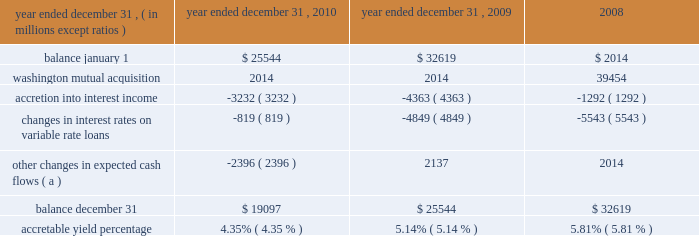Notes to consolidated financial statements 236 jpmorgan chase & co./2010 annual report the table below sets forth the accretable yield activity for the firm 2019s pci consumer loans for the years ended december 31 , 2010 , 2009 and .
( a ) other changes in expected cash flows may vary from period to period as the firm continues to refine its cash flow model and periodically updates model assumptions .
For the years ended december 31 , 2010 and 2009 , other changes in expected cash flows were principally driven by changes in prepayment assumptions , as well as reclassification to the nonaccretable difference .
Such changes are expected to have an insignificant impact on the accretable yield percentage .
The factors that most significantly affect estimates of gross cash flows expected to be collected , and accordingly the accretable yield balance , include : ( i ) changes in the benchmark interest rate indices for variable rate products such as option arm and home equity loans ; and ( ii ) changes in prepayment assump- tions .
To date , the decrease in the accretable yield percentage has been primarily related to a decrease in interest rates on vari- able-rate loans and , to a lesser extent , extended loan liquida- tion periods .
Certain events , such as extended loan liquidation periods , affect the timing of expected cash flows but not the amount of cash expected to be received ( i.e. , the accretable yield balance ) .
Extended loan liquidation periods reduce the accretable yield percentage because the same accretable yield balance is recognized against a higher-than-expected loan balance over a longer-than-expected period of time. .
What was the percentage change in the accretable yield activity for the firm 2019s pci consumer loans in 2010? 
Computations: ((19097 - 25544) / 25544)
Answer: -0.25239. 